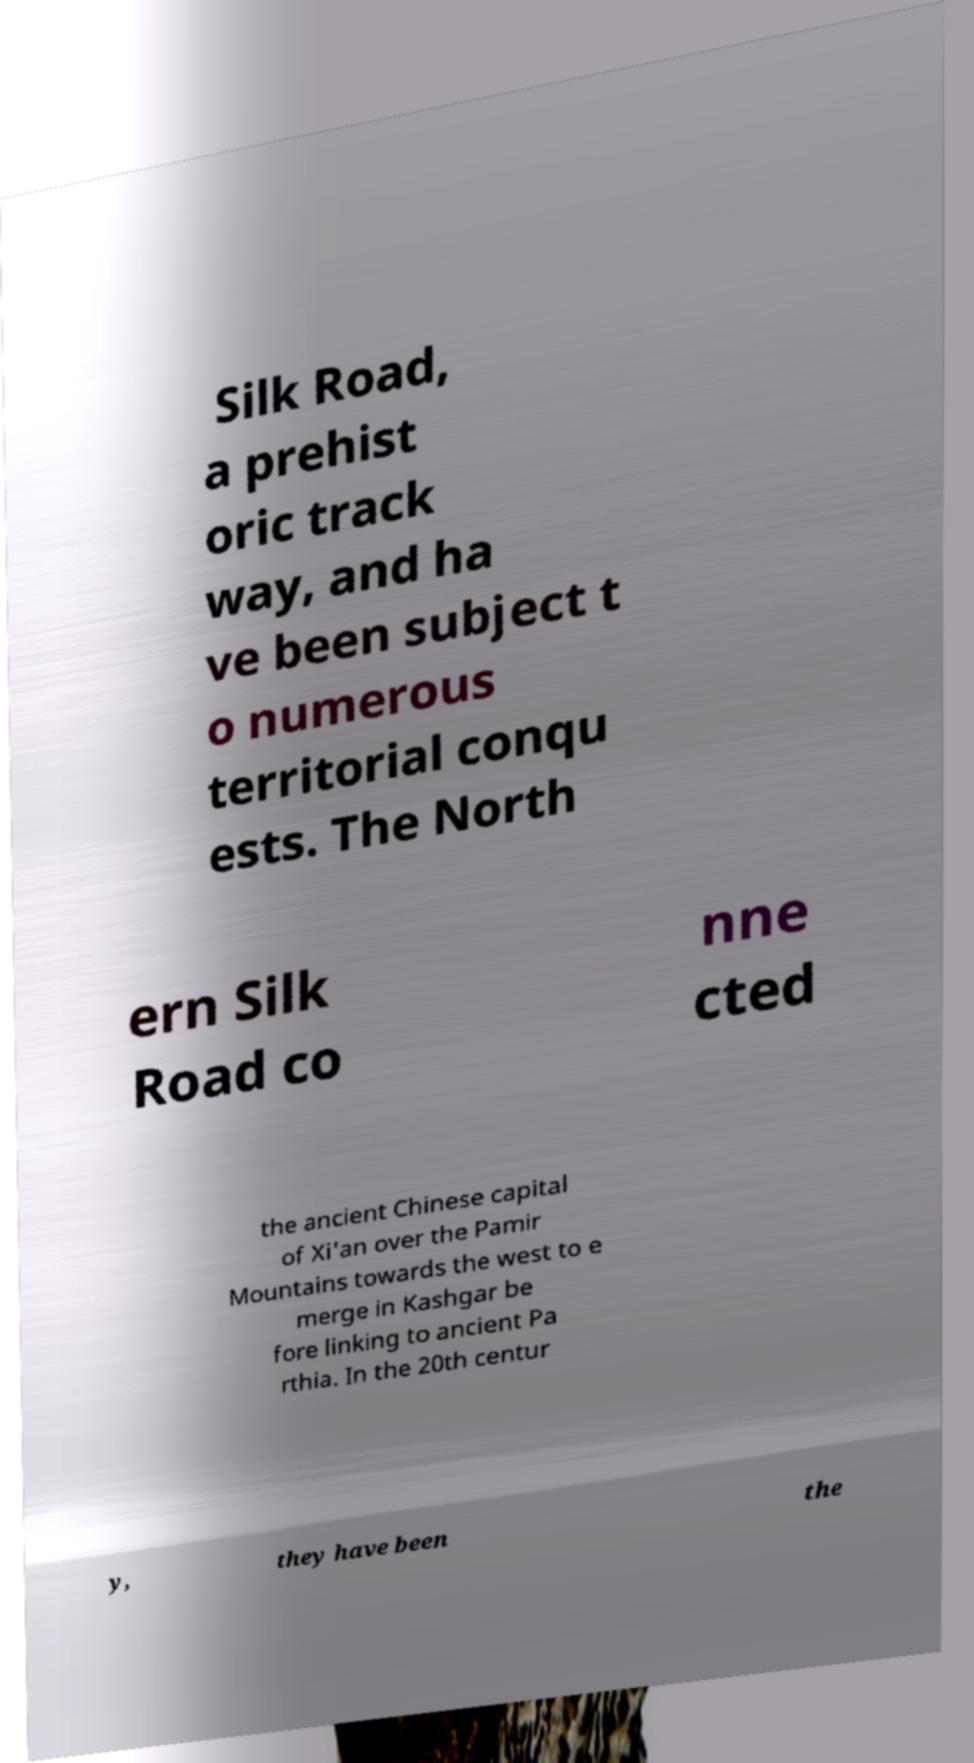Could you extract and type out the text from this image? Silk Road, a prehist oric track way, and ha ve been subject t o numerous territorial conqu ests. The North ern Silk Road co nne cted the ancient Chinese capital of Xi'an over the Pamir Mountains towards the west to e merge in Kashgar be fore linking to ancient Pa rthia. In the 20th centur y, they have been the 